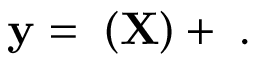Convert formula to latex. <formula><loc_0><loc_0><loc_500><loc_500>y = \tau ( X ) + \eta .</formula> 